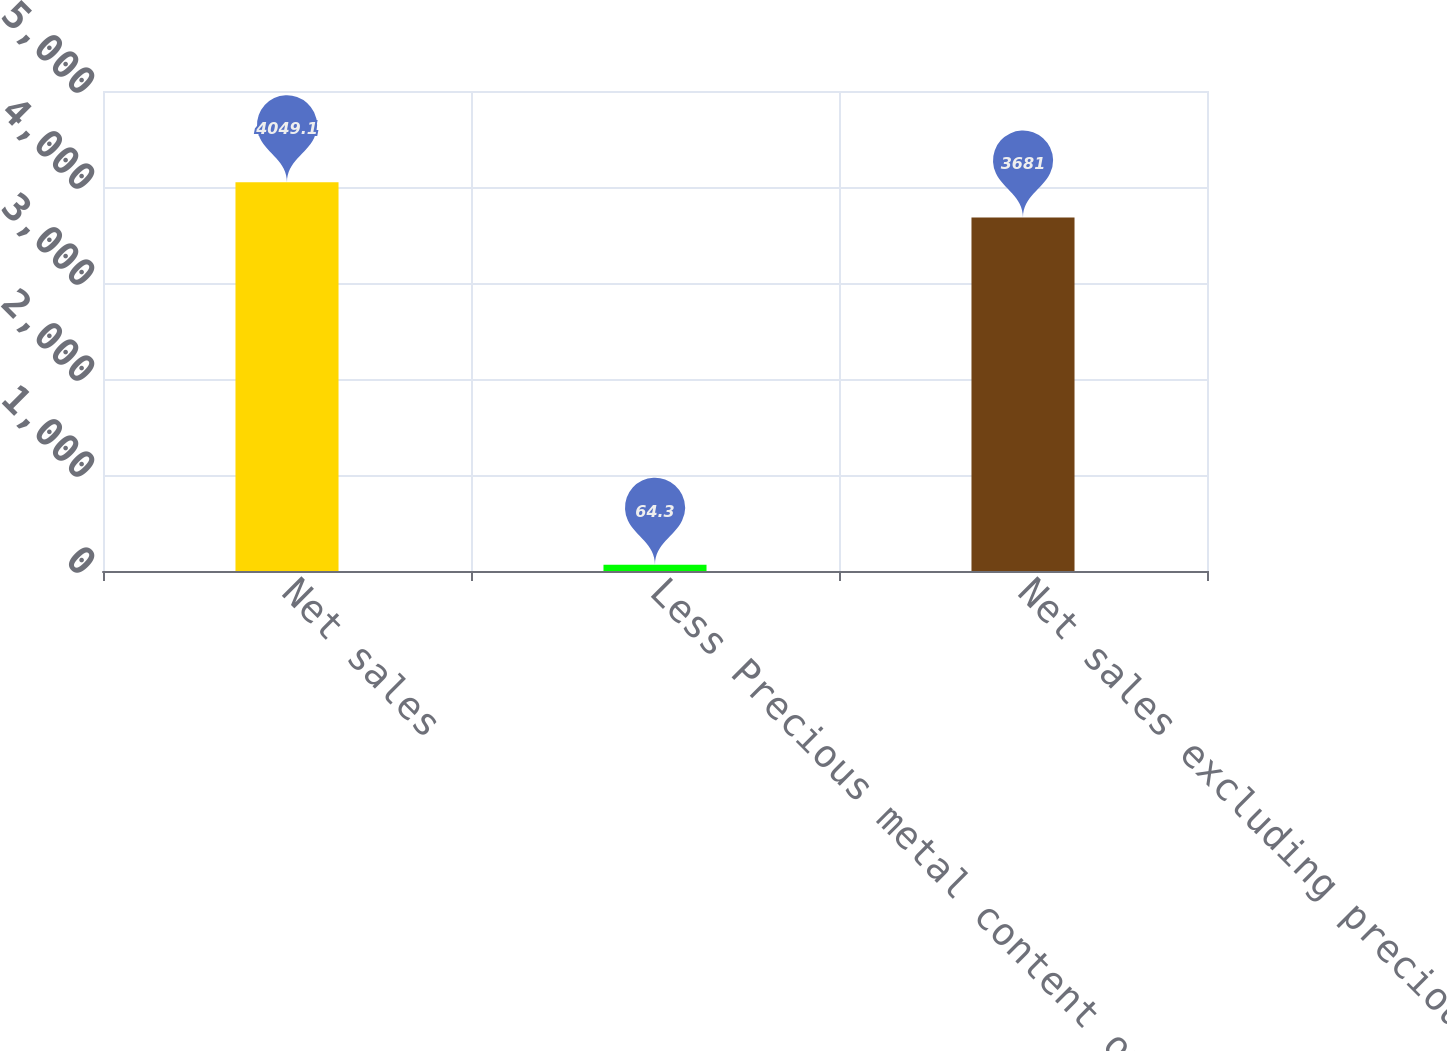<chart> <loc_0><loc_0><loc_500><loc_500><bar_chart><fcel>Net sales<fcel>Less Precious metal content of<fcel>Net sales excluding precious<nl><fcel>4049.1<fcel>64.3<fcel>3681<nl></chart> 